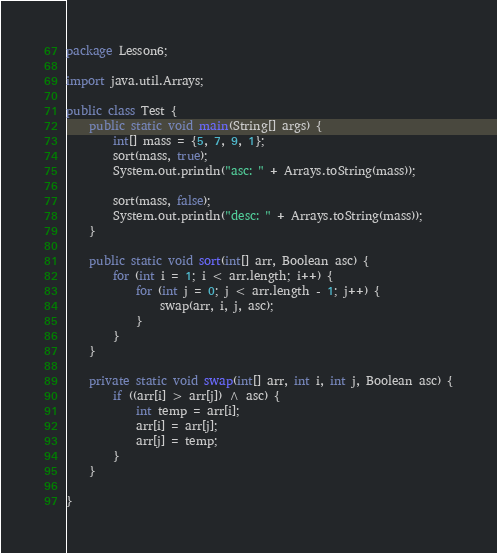<code> <loc_0><loc_0><loc_500><loc_500><_Java_>package Lesson6;

import java.util.Arrays;

public class Test {
    public static void main(String[] args) {
        int[] mass = {5, 7, 9, 1};
        sort(mass, true);
        System.out.println("asc: " + Arrays.toString(mass));

        sort(mass, false);
        System.out.println("desc: " + Arrays.toString(mass));
    }

    public static void sort(int[] arr, Boolean asc) {
        for (int i = 1; i < arr.length; i++) {
            for (int j = 0; j < arr.length - 1; j++) {
                swap(arr, i, j, asc);
            }
        }
    }

    private static void swap(int[] arr, int i, int j, Boolean asc) {
        if ((arr[i] > arr[j]) ^ asc) {
            int temp = arr[i];
            arr[i] = arr[j];
            arr[j] = temp;
        }
    }

}

</code> 